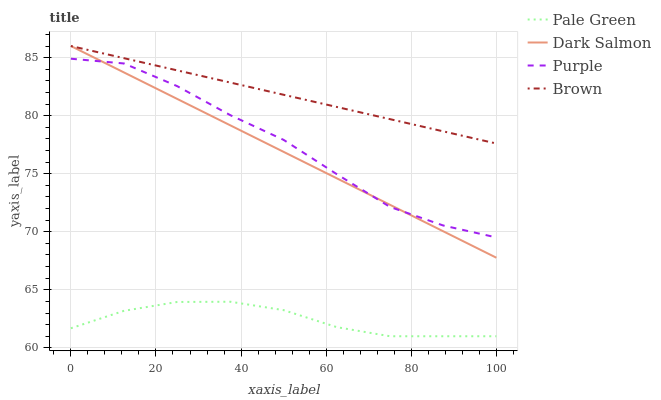Does Pale Green have the minimum area under the curve?
Answer yes or no. Yes. Does Brown have the maximum area under the curve?
Answer yes or no. Yes. Does Brown have the minimum area under the curve?
Answer yes or no. No. Does Pale Green have the maximum area under the curve?
Answer yes or no. No. Is Brown the smoothest?
Answer yes or no. Yes. Is Purple the roughest?
Answer yes or no. Yes. Is Pale Green the smoothest?
Answer yes or no. No. Is Pale Green the roughest?
Answer yes or no. No. Does Pale Green have the lowest value?
Answer yes or no. Yes. Does Brown have the lowest value?
Answer yes or no. No. Does Dark Salmon have the highest value?
Answer yes or no. Yes. Does Pale Green have the highest value?
Answer yes or no. No. Is Pale Green less than Brown?
Answer yes or no. Yes. Is Brown greater than Pale Green?
Answer yes or no. Yes. Does Purple intersect Dark Salmon?
Answer yes or no. Yes. Is Purple less than Dark Salmon?
Answer yes or no. No. Is Purple greater than Dark Salmon?
Answer yes or no. No. Does Pale Green intersect Brown?
Answer yes or no. No. 